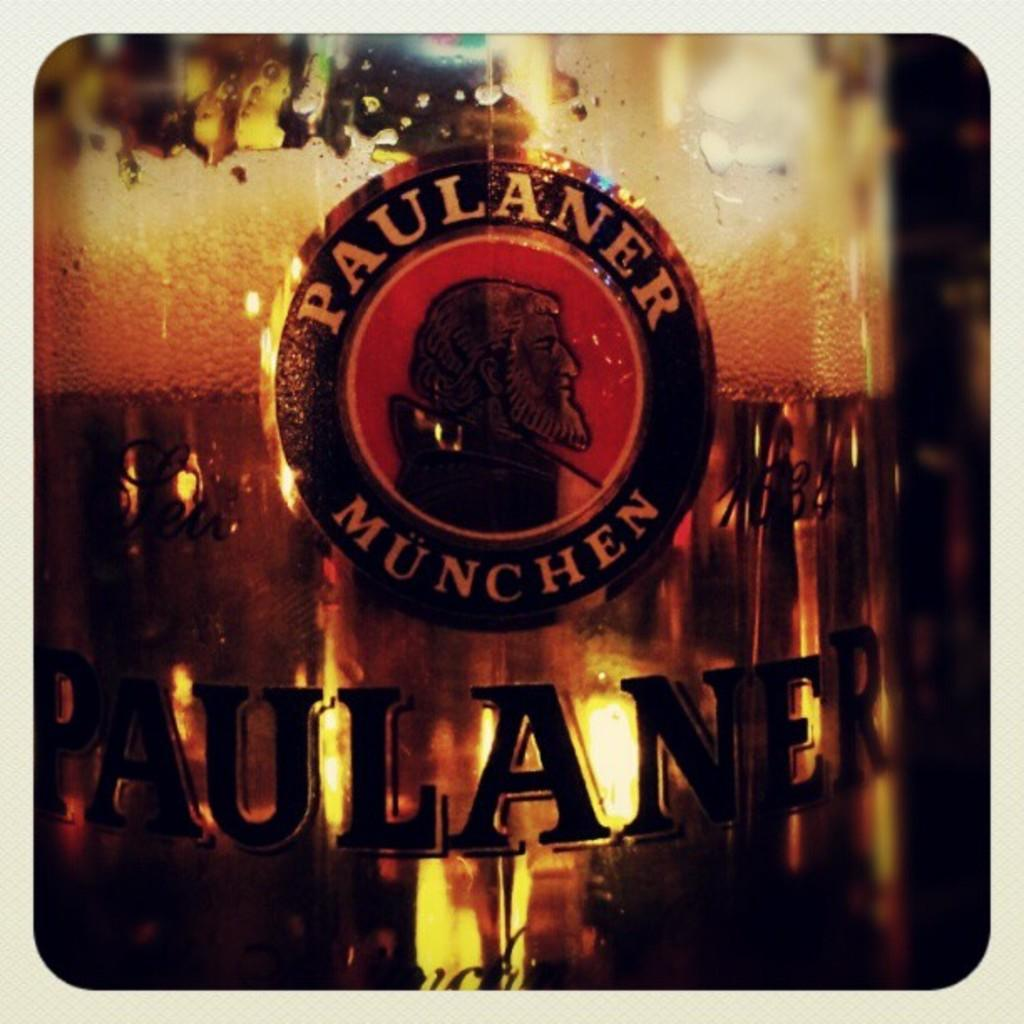<image>
Provide a brief description of the given image. A close-up view of a glass of beer with the Paulaner Munchen emblem. 